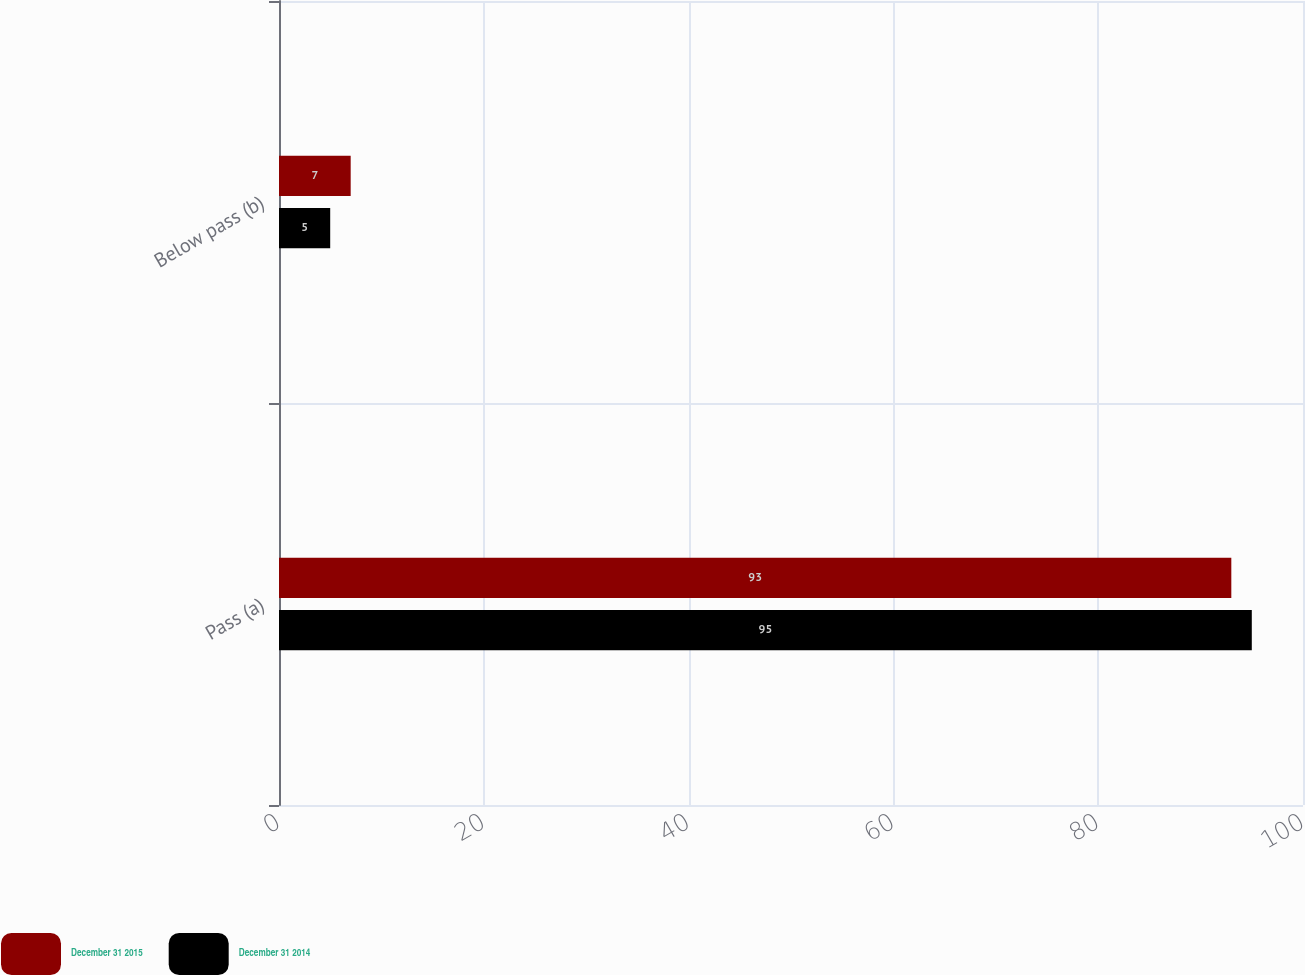Convert chart. <chart><loc_0><loc_0><loc_500><loc_500><stacked_bar_chart><ecel><fcel>Pass (a)<fcel>Below pass (b)<nl><fcel>December 31 2015<fcel>93<fcel>7<nl><fcel>December 31 2014<fcel>95<fcel>5<nl></chart> 